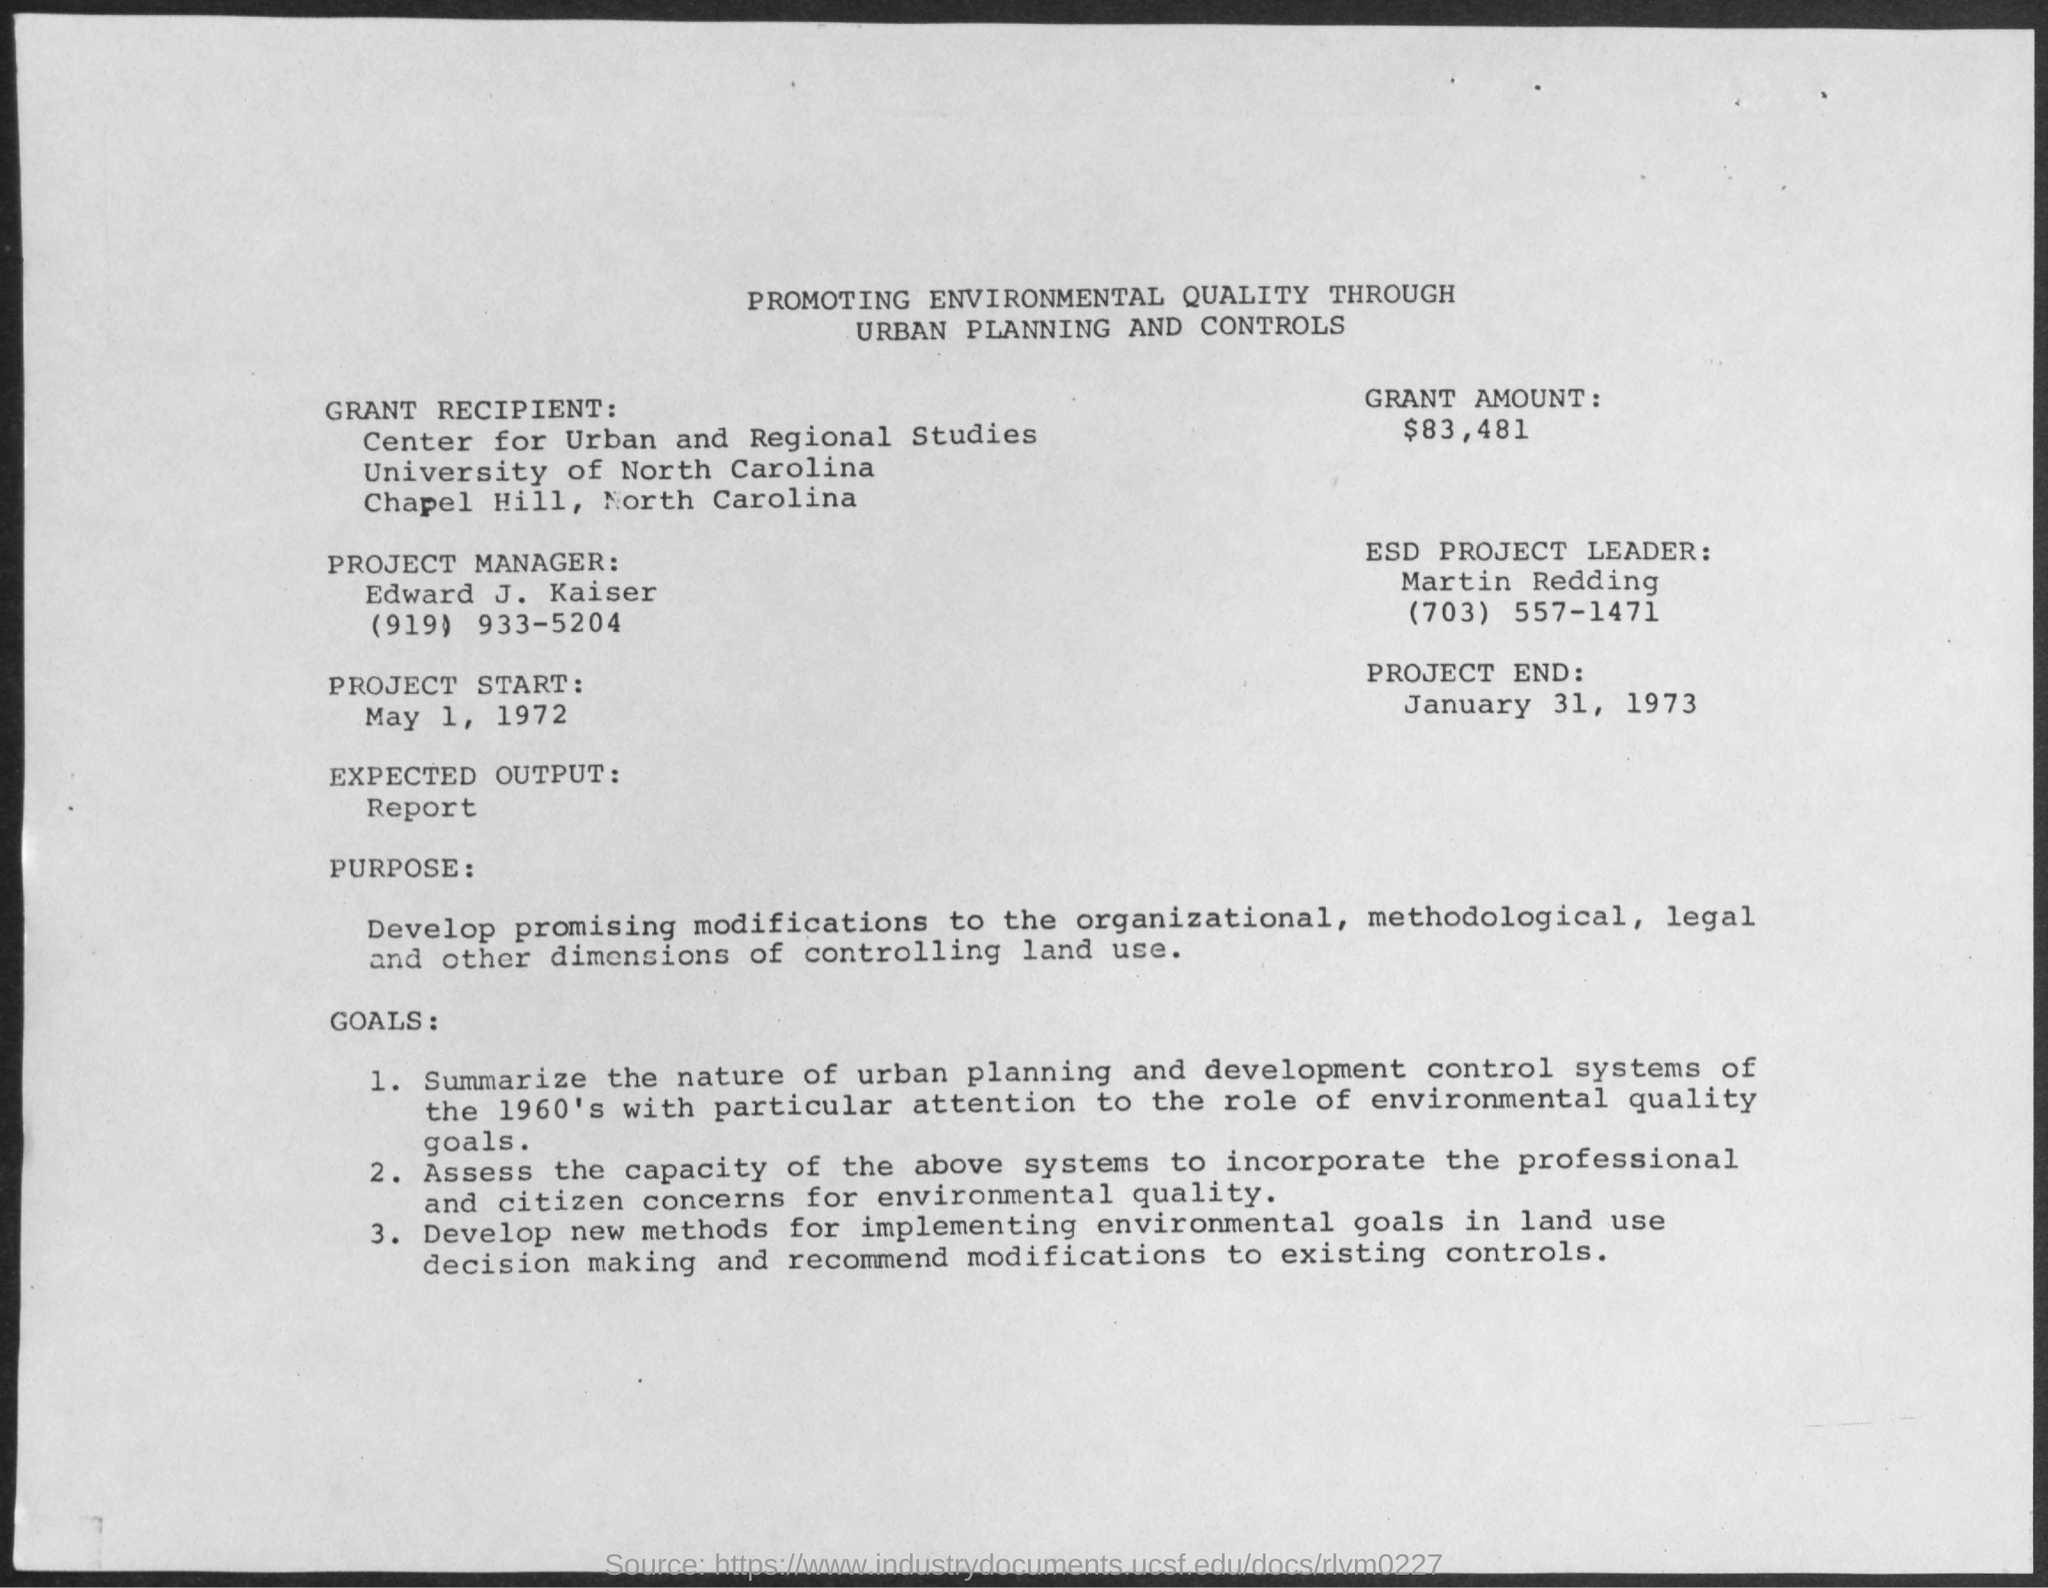Mention a couple of crucial points in this snapshot. The ESD project leader is Martin Redding. The grant amount is $83,481. The contact number of Edward J. Kaiser is (919) 933-5204. The University of North Carolina is the name of the university. The project manager's name is Edward J. Kaiser. 